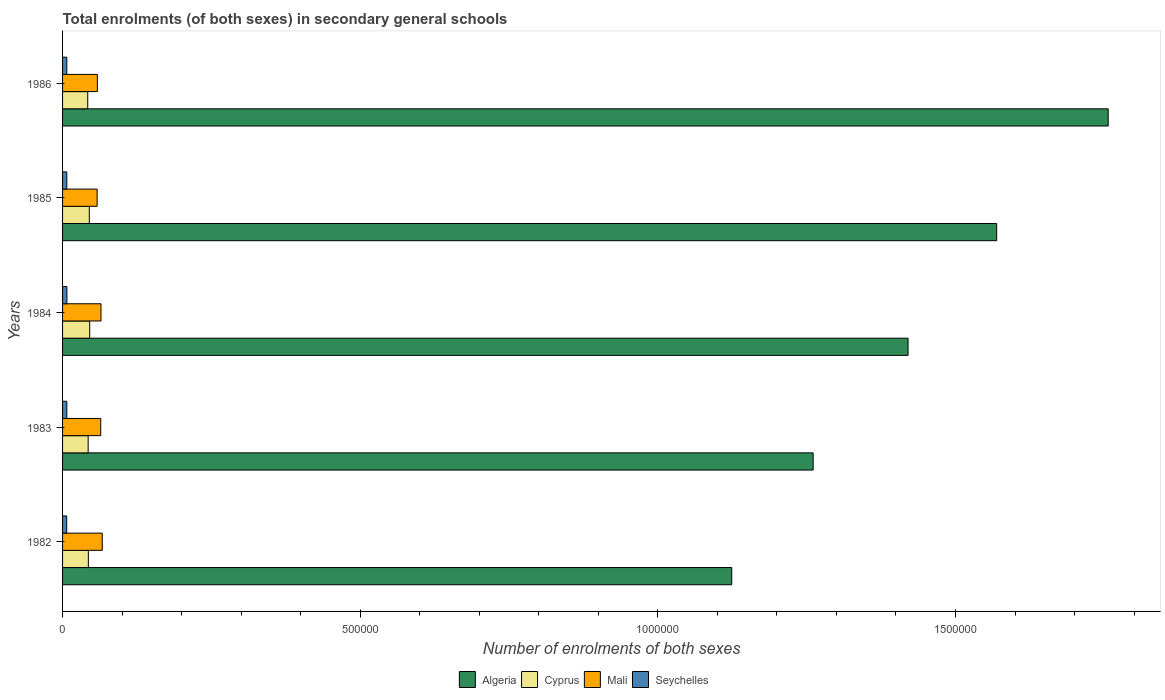How many different coloured bars are there?
Provide a short and direct response. 4. How many groups of bars are there?
Provide a short and direct response. 5. Are the number of bars per tick equal to the number of legend labels?
Your response must be concise. Yes. Are the number of bars on each tick of the Y-axis equal?
Provide a succinct answer. Yes. How many bars are there on the 4th tick from the top?
Make the answer very short. 4. In how many cases, is the number of bars for a given year not equal to the number of legend labels?
Ensure brevity in your answer.  0. What is the number of enrolments in secondary schools in Mali in 1982?
Provide a short and direct response. 6.67e+04. Across all years, what is the maximum number of enrolments in secondary schools in Mali?
Your answer should be compact. 6.67e+04. Across all years, what is the minimum number of enrolments in secondary schools in Mali?
Your answer should be very brief. 5.81e+04. What is the total number of enrolments in secondary schools in Algeria in the graph?
Give a very brief answer. 7.13e+06. What is the difference between the number of enrolments in secondary schools in Mali in 1982 and that in 1983?
Provide a short and direct response. 2521. What is the difference between the number of enrolments in secondary schools in Seychelles in 1983 and the number of enrolments in secondary schools in Cyprus in 1986?
Provide a short and direct response. -3.51e+04. What is the average number of enrolments in secondary schools in Algeria per year?
Provide a short and direct response. 1.43e+06. In the year 1983, what is the difference between the number of enrolments in secondary schools in Cyprus and number of enrolments in secondary schools in Mali?
Offer a terse response. -2.11e+04. In how many years, is the number of enrolments in secondary schools in Algeria greater than 500000 ?
Make the answer very short. 5. What is the ratio of the number of enrolments in secondary schools in Cyprus in 1983 to that in 1986?
Ensure brevity in your answer.  1.02. Is the number of enrolments in secondary schools in Algeria in 1983 less than that in 1986?
Give a very brief answer. Yes. Is the difference between the number of enrolments in secondary schools in Cyprus in 1983 and 1985 greater than the difference between the number of enrolments in secondary schools in Mali in 1983 and 1985?
Your response must be concise. No. What is the difference between the highest and the second highest number of enrolments in secondary schools in Mali?
Give a very brief answer. 2107. What is the difference between the highest and the lowest number of enrolments in secondary schools in Algeria?
Offer a terse response. 6.32e+05. In how many years, is the number of enrolments in secondary schools in Cyprus greater than the average number of enrolments in secondary schools in Cyprus taken over all years?
Your response must be concise. 2. Is the sum of the number of enrolments in secondary schools in Mali in 1983 and 1986 greater than the maximum number of enrolments in secondary schools in Seychelles across all years?
Your response must be concise. Yes. Is it the case that in every year, the sum of the number of enrolments in secondary schools in Algeria and number of enrolments in secondary schools in Cyprus is greater than the sum of number of enrolments in secondary schools in Seychelles and number of enrolments in secondary schools in Mali?
Keep it short and to the point. Yes. What does the 2nd bar from the top in 1986 represents?
Provide a short and direct response. Mali. What does the 2nd bar from the bottom in 1985 represents?
Ensure brevity in your answer.  Cyprus. Is it the case that in every year, the sum of the number of enrolments in secondary schools in Algeria and number of enrolments in secondary schools in Mali is greater than the number of enrolments in secondary schools in Cyprus?
Ensure brevity in your answer.  Yes. How many bars are there?
Give a very brief answer. 20. Are all the bars in the graph horizontal?
Ensure brevity in your answer.  Yes. How many years are there in the graph?
Give a very brief answer. 5. Does the graph contain any zero values?
Make the answer very short. No. How are the legend labels stacked?
Provide a short and direct response. Horizontal. What is the title of the graph?
Your answer should be compact. Total enrolments (of both sexes) in secondary general schools. Does "Middle East & North Africa (all income levels)" appear as one of the legend labels in the graph?
Your answer should be very brief. No. What is the label or title of the X-axis?
Offer a very short reply. Number of enrolments of both sexes. What is the label or title of the Y-axis?
Offer a terse response. Years. What is the Number of enrolments of both sexes in Algeria in 1982?
Ensure brevity in your answer.  1.12e+06. What is the Number of enrolments of both sexes in Cyprus in 1982?
Ensure brevity in your answer.  4.33e+04. What is the Number of enrolments of both sexes in Mali in 1982?
Give a very brief answer. 6.67e+04. What is the Number of enrolments of both sexes of Seychelles in 1982?
Your response must be concise. 6935. What is the Number of enrolments of both sexes of Algeria in 1983?
Make the answer very short. 1.26e+06. What is the Number of enrolments of both sexes in Cyprus in 1983?
Provide a succinct answer. 4.30e+04. What is the Number of enrolments of both sexes of Mali in 1983?
Make the answer very short. 6.41e+04. What is the Number of enrolments of both sexes of Seychelles in 1983?
Keep it short and to the point. 7144. What is the Number of enrolments of both sexes of Algeria in 1984?
Provide a short and direct response. 1.42e+06. What is the Number of enrolments of both sexes of Cyprus in 1984?
Offer a terse response. 4.56e+04. What is the Number of enrolments of both sexes of Mali in 1984?
Ensure brevity in your answer.  6.46e+04. What is the Number of enrolments of both sexes of Seychelles in 1984?
Offer a very short reply. 7254. What is the Number of enrolments of both sexes in Algeria in 1985?
Give a very brief answer. 1.57e+06. What is the Number of enrolments of both sexes of Cyprus in 1985?
Give a very brief answer. 4.49e+04. What is the Number of enrolments of both sexes of Mali in 1985?
Keep it short and to the point. 5.81e+04. What is the Number of enrolments of both sexes in Seychelles in 1985?
Make the answer very short. 7125. What is the Number of enrolments of both sexes in Algeria in 1986?
Provide a short and direct response. 1.76e+06. What is the Number of enrolments of both sexes of Cyprus in 1986?
Make the answer very short. 4.23e+04. What is the Number of enrolments of both sexes in Mali in 1986?
Provide a succinct answer. 5.84e+04. What is the Number of enrolments of both sexes in Seychelles in 1986?
Your answer should be compact. 7101. Across all years, what is the maximum Number of enrolments of both sexes in Algeria?
Your answer should be compact. 1.76e+06. Across all years, what is the maximum Number of enrolments of both sexes of Cyprus?
Offer a terse response. 4.56e+04. Across all years, what is the maximum Number of enrolments of both sexes in Mali?
Provide a short and direct response. 6.67e+04. Across all years, what is the maximum Number of enrolments of both sexes of Seychelles?
Give a very brief answer. 7254. Across all years, what is the minimum Number of enrolments of both sexes in Algeria?
Provide a short and direct response. 1.12e+06. Across all years, what is the minimum Number of enrolments of both sexes of Cyprus?
Your response must be concise. 4.23e+04. Across all years, what is the minimum Number of enrolments of both sexes in Mali?
Make the answer very short. 5.81e+04. Across all years, what is the minimum Number of enrolments of both sexes of Seychelles?
Make the answer very short. 6935. What is the total Number of enrolments of both sexes of Algeria in the graph?
Provide a short and direct response. 7.13e+06. What is the total Number of enrolments of both sexes of Cyprus in the graph?
Ensure brevity in your answer.  2.19e+05. What is the total Number of enrolments of both sexes of Mali in the graph?
Keep it short and to the point. 3.12e+05. What is the total Number of enrolments of both sexes of Seychelles in the graph?
Provide a succinct answer. 3.56e+04. What is the difference between the Number of enrolments of both sexes in Algeria in 1982 and that in 1983?
Provide a succinct answer. -1.37e+05. What is the difference between the Number of enrolments of both sexes of Cyprus in 1982 and that in 1983?
Give a very brief answer. 338. What is the difference between the Number of enrolments of both sexes of Mali in 1982 and that in 1983?
Provide a short and direct response. 2521. What is the difference between the Number of enrolments of both sexes in Seychelles in 1982 and that in 1983?
Your answer should be very brief. -209. What is the difference between the Number of enrolments of both sexes in Algeria in 1982 and that in 1984?
Offer a terse response. -2.96e+05. What is the difference between the Number of enrolments of both sexes in Cyprus in 1982 and that in 1984?
Your answer should be very brief. -2261. What is the difference between the Number of enrolments of both sexes of Mali in 1982 and that in 1984?
Provide a succinct answer. 2107. What is the difference between the Number of enrolments of both sexes of Seychelles in 1982 and that in 1984?
Your response must be concise. -319. What is the difference between the Number of enrolments of both sexes in Algeria in 1982 and that in 1985?
Offer a terse response. -4.45e+05. What is the difference between the Number of enrolments of both sexes in Cyprus in 1982 and that in 1985?
Offer a very short reply. -1557. What is the difference between the Number of enrolments of both sexes in Mali in 1982 and that in 1985?
Your answer should be very brief. 8594. What is the difference between the Number of enrolments of both sexes in Seychelles in 1982 and that in 1985?
Your answer should be compact. -190. What is the difference between the Number of enrolments of both sexes of Algeria in 1982 and that in 1986?
Provide a succinct answer. -6.32e+05. What is the difference between the Number of enrolments of both sexes in Cyprus in 1982 and that in 1986?
Your answer should be very brief. 1053. What is the difference between the Number of enrolments of both sexes of Mali in 1982 and that in 1986?
Keep it short and to the point. 8224. What is the difference between the Number of enrolments of both sexes of Seychelles in 1982 and that in 1986?
Give a very brief answer. -166. What is the difference between the Number of enrolments of both sexes in Algeria in 1983 and that in 1984?
Your answer should be very brief. -1.59e+05. What is the difference between the Number of enrolments of both sexes of Cyprus in 1983 and that in 1984?
Offer a very short reply. -2599. What is the difference between the Number of enrolments of both sexes in Mali in 1983 and that in 1984?
Your answer should be very brief. -414. What is the difference between the Number of enrolments of both sexes in Seychelles in 1983 and that in 1984?
Keep it short and to the point. -110. What is the difference between the Number of enrolments of both sexes in Algeria in 1983 and that in 1985?
Offer a very short reply. -3.08e+05. What is the difference between the Number of enrolments of both sexes in Cyprus in 1983 and that in 1985?
Provide a succinct answer. -1895. What is the difference between the Number of enrolments of both sexes of Mali in 1983 and that in 1985?
Offer a terse response. 6073. What is the difference between the Number of enrolments of both sexes of Seychelles in 1983 and that in 1985?
Make the answer very short. 19. What is the difference between the Number of enrolments of both sexes of Algeria in 1983 and that in 1986?
Provide a succinct answer. -4.96e+05. What is the difference between the Number of enrolments of both sexes in Cyprus in 1983 and that in 1986?
Give a very brief answer. 715. What is the difference between the Number of enrolments of both sexes in Mali in 1983 and that in 1986?
Your response must be concise. 5703. What is the difference between the Number of enrolments of both sexes in Algeria in 1984 and that in 1985?
Give a very brief answer. -1.49e+05. What is the difference between the Number of enrolments of both sexes in Cyprus in 1984 and that in 1985?
Make the answer very short. 704. What is the difference between the Number of enrolments of both sexes in Mali in 1984 and that in 1985?
Your answer should be compact. 6487. What is the difference between the Number of enrolments of both sexes of Seychelles in 1984 and that in 1985?
Provide a short and direct response. 129. What is the difference between the Number of enrolments of both sexes of Algeria in 1984 and that in 1986?
Keep it short and to the point. -3.36e+05. What is the difference between the Number of enrolments of both sexes of Cyprus in 1984 and that in 1986?
Ensure brevity in your answer.  3314. What is the difference between the Number of enrolments of both sexes in Mali in 1984 and that in 1986?
Your response must be concise. 6117. What is the difference between the Number of enrolments of both sexes of Seychelles in 1984 and that in 1986?
Your answer should be very brief. 153. What is the difference between the Number of enrolments of both sexes in Algeria in 1985 and that in 1986?
Provide a succinct answer. -1.87e+05. What is the difference between the Number of enrolments of both sexes in Cyprus in 1985 and that in 1986?
Make the answer very short. 2610. What is the difference between the Number of enrolments of both sexes of Mali in 1985 and that in 1986?
Your response must be concise. -370. What is the difference between the Number of enrolments of both sexes in Seychelles in 1985 and that in 1986?
Make the answer very short. 24. What is the difference between the Number of enrolments of both sexes in Algeria in 1982 and the Number of enrolments of both sexes in Cyprus in 1983?
Provide a short and direct response. 1.08e+06. What is the difference between the Number of enrolments of both sexes of Algeria in 1982 and the Number of enrolments of both sexes of Mali in 1983?
Make the answer very short. 1.06e+06. What is the difference between the Number of enrolments of both sexes of Algeria in 1982 and the Number of enrolments of both sexes of Seychelles in 1983?
Offer a very short reply. 1.12e+06. What is the difference between the Number of enrolments of both sexes of Cyprus in 1982 and the Number of enrolments of both sexes of Mali in 1983?
Provide a succinct answer. -2.08e+04. What is the difference between the Number of enrolments of both sexes of Cyprus in 1982 and the Number of enrolments of both sexes of Seychelles in 1983?
Your response must be concise. 3.62e+04. What is the difference between the Number of enrolments of both sexes in Mali in 1982 and the Number of enrolments of both sexes in Seychelles in 1983?
Provide a short and direct response. 5.95e+04. What is the difference between the Number of enrolments of both sexes in Algeria in 1982 and the Number of enrolments of both sexes in Cyprus in 1984?
Keep it short and to the point. 1.08e+06. What is the difference between the Number of enrolments of both sexes of Algeria in 1982 and the Number of enrolments of both sexes of Mali in 1984?
Ensure brevity in your answer.  1.06e+06. What is the difference between the Number of enrolments of both sexes in Algeria in 1982 and the Number of enrolments of both sexes in Seychelles in 1984?
Provide a succinct answer. 1.12e+06. What is the difference between the Number of enrolments of both sexes in Cyprus in 1982 and the Number of enrolments of both sexes in Mali in 1984?
Make the answer very short. -2.12e+04. What is the difference between the Number of enrolments of both sexes in Cyprus in 1982 and the Number of enrolments of both sexes in Seychelles in 1984?
Make the answer very short. 3.61e+04. What is the difference between the Number of enrolments of both sexes in Mali in 1982 and the Number of enrolments of both sexes in Seychelles in 1984?
Provide a succinct answer. 5.94e+04. What is the difference between the Number of enrolments of both sexes of Algeria in 1982 and the Number of enrolments of both sexes of Cyprus in 1985?
Keep it short and to the point. 1.08e+06. What is the difference between the Number of enrolments of both sexes in Algeria in 1982 and the Number of enrolments of both sexes in Mali in 1985?
Give a very brief answer. 1.07e+06. What is the difference between the Number of enrolments of both sexes of Algeria in 1982 and the Number of enrolments of both sexes of Seychelles in 1985?
Your answer should be very brief. 1.12e+06. What is the difference between the Number of enrolments of both sexes in Cyprus in 1982 and the Number of enrolments of both sexes in Mali in 1985?
Provide a succinct answer. -1.47e+04. What is the difference between the Number of enrolments of both sexes of Cyprus in 1982 and the Number of enrolments of both sexes of Seychelles in 1985?
Keep it short and to the point. 3.62e+04. What is the difference between the Number of enrolments of both sexes in Mali in 1982 and the Number of enrolments of both sexes in Seychelles in 1985?
Your answer should be very brief. 5.95e+04. What is the difference between the Number of enrolments of both sexes in Algeria in 1982 and the Number of enrolments of both sexes in Cyprus in 1986?
Provide a succinct answer. 1.08e+06. What is the difference between the Number of enrolments of both sexes in Algeria in 1982 and the Number of enrolments of both sexes in Mali in 1986?
Your answer should be compact. 1.07e+06. What is the difference between the Number of enrolments of both sexes of Algeria in 1982 and the Number of enrolments of both sexes of Seychelles in 1986?
Provide a succinct answer. 1.12e+06. What is the difference between the Number of enrolments of both sexes in Cyprus in 1982 and the Number of enrolments of both sexes in Mali in 1986?
Offer a very short reply. -1.51e+04. What is the difference between the Number of enrolments of both sexes in Cyprus in 1982 and the Number of enrolments of both sexes in Seychelles in 1986?
Your response must be concise. 3.62e+04. What is the difference between the Number of enrolments of both sexes of Mali in 1982 and the Number of enrolments of both sexes of Seychelles in 1986?
Provide a succinct answer. 5.96e+04. What is the difference between the Number of enrolments of both sexes in Algeria in 1983 and the Number of enrolments of both sexes in Cyprus in 1984?
Give a very brief answer. 1.22e+06. What is the difference between the Number of enrolments of both sexes in Algeria in 1983 and the Number of enrolments of both sexes in Mali in 1984?
Your answer should be compact. 1.20e+06. What is the difference between the Number of enrolments of both sexes of Algeria in 1983 and the Number of enrolments of both sexes of Seychelles in 1984?
Make the answer very short. 1.25e+06. What is the difference between the Number of enrolments of both sexes of Cyprus in 1983 and the Number of enrolments of both sexes of Mali in 1984?
Give a very brief answer. -2.16e+04. What is the difference between the Number of enrolments of both sexes of Cyprus in 1983 and the Number of enrolments of both sexes of Seychelles in 1984?
Offer a very short reply. 3.57e+04. What is the difference between the Number of enrolments of both sexes of Mali in 1983 and the Number of enrolments of both sexes of Seychelles in 1984?
Your response must be concise. 5.69e+04. What is the difference between the Number of enrolments of both sexes in Algeria in 1983 and the Number of enrolments of both sexes in Cyprus in 1985?
Your answer should be very brief. 1.22e+06. What is the difference between the Number of enrolments of both sexes in Algeria in 1983 and the Number of enrolments of both sexes in Mali in 1985?
Make the answer very short. 1.20e+06. What is the difference between the Number of enrolments of both sexes in Algeria in 1983 and the Number of enrolments of both sexes in Seychelles in 1985?
Offer a very short reply. 1.25e+06. What is the difference between the Number of enrolments of both sexes in Cyprus in 1983 and the Number of enrolments of both sexes in Mali in 1985?
Your answer should be very brief. -1.51e+04. What is the difference between the Number of enrolments of both sexes in Cyprus in 1983 and the Number of enrolments of both sexes in Seychelles in 1985?
Give a very brief answer. 3.59e+04. What is the difference between the Number of enrolments of both sexes in Mali in 1983 and the Number of enrolments of both sexes in Seychelles in 1985?
Offer a terse response. 5.70e+04. What is the difference between the Number of enrolments of both sexes in Algeria in 1983 and the Number of enrolments of both sexes in Cyprus in 1986?
Keep it short and to the point. 1.22e+06. What is the difference between the Number of enrolments of both sexes in Algeria in 1983 and the Number of enrolments of both sexes in Mali in 1986?
Offer a very short reply. 1.20e+06. What is the difference between the Number of enrolments of both sexes of Algeria in 1983 and the Number of enrolments of both sexes of Seychelles in 1986?
Keep it short and to the point. 1.25e+06. What is the difference between the Number of enrolments of both sexes of Cyprus in 1983 and the Number of enrolments of both sexes of Mali in 1986?
Give a very brief answer. -1.54e+04. What is the difference between the Number of enrolments of both sexes in Cyprus in 1983 and the Number of enrolments of both sexes in Seychelles in 1986?
Keep it short and to the point. 3.59e+04. What is the difference between the Number of enrolments of both sexes of Mali in 1983 and the Number of enrolments of both sexes of Seychelles in 1986?
Your response must be concise. 5.70e+04. What is the difference between the Number of enrolments of both sexes in Algeria in 1984 and the Number of enrolments of both sexes in Cyprus in 1985?
Give a very brief answer. 1.38e+06. What is the difference between the Number of enrolments of both sexes of Algeria in 1984 and the Number of enrolments of both sexes of Mali in 1985?
Keep it short and to the point. 1.36e+06. What is the difference between the Number of enrolments of both sexes in Algeria in 1984 and the Number of enrolments of both sexes in Seychelles in 1985?
Ensure brevity in your answer.  1.41e+06. What is the difference between the Number of enrolments of both sexes in Cyprus in 1984 and the Number of enrolments of both sexes in Mali in 1985?
Provide a short and direct response. -1.25e+04. What is the difference between the Number of enrolments of both sexes in Cyprus in 1984 and the Number of enrolments of both sexes in Seychelles in 1985?
Make the answer very short. 3.85e+04. What is the difference between the Number of enrolments of both sexes of Mali in 1984 and the Number of enrolments of both sexes of Seychelles in 1985?
Give a very brief answer. 5.74e+04. What is the difference between the Number of enrolments of both sexes in Algeria in 1984 and the Number of enrolments of both sexes in Cyprus in 1986?
Keep it short and to the point. 1.38e+06. What is the difference between the Number of enrolments of both sexes of Algeria in 1984 and the Number of enrolments of both sexes of Mali in 1986?
Ensure brevity in your answer.  1.36e+06. What is the difference between the Number of enrolments of both sexes of Algeria in 1984 and the Number of enrolments of both sexes of Seychelles in 1986?
Provide a short and direct response. 1.41e+06. What is the difference between the Number of enrolments of both sexes in Cyprus in 1984 and the Number of enrolments of both sexes in Mali in 1986?
Ensure brevity in your answer.  -1.28e+04. What is the difference between the Number of enrolments of both sexes in Cyprus in 1984 and the Number of enrolments of both sexes in Seychelles in 1986?
Ensure brevity in your answer.  3.85e+04. What is the difference between the Number of enrolments of both sexes in Mali in 1984 and the Number of enrolments of both sexes in Seychelles in 1986?
Ensure brevity in your answer.  5.75e+04. What is the difference between the Number of enrolments of both sexes in Algeria in 1985 and the Number of enrolments of both sexes in Cyprus in 1986?
Offer a very short reply. 1.53e+06. What is the difference between the Number of enrolments of both sexes in Algeria in 1985 and the Number of enrolments of both sexes in Mali in 1986?
Offer a terse response. 1.51e+06. What is the difference between the Number of enrolments of both sexes in Algeria in 1985 and the Number of enrolments of both sexes in Seychelles in 1986?
Ensure brevity in your answer.  1.56e+06. What is the difference between the Number of enrolments of both sexes of Cyprus in 1985 and the Number of enrolments of both sexes of Mali in 1986?
Offer a terse response. -1.36e+04. What is the difference between the Number of enrolments of both sexes in Cyprus in 1985 and the Number of enrolments of both sexes in Seychelles in 1986?
Your answer should be compact. 3.78e+04. What is the difference between the Number of enrolments of both sexes of Mali in 1985 and the Number of enrolments of both sexes of Seychelles in 1986?
Ensure brevity in your answer.  5.10e+04. What is the average Number of enrolments of both sexes of Algeria per year?
Your answer should be compact. 1.43e+06. What is the average Number of enrolments of both sexes of Cyprus per year?
Provide a succinct answer. 4.38e+04. What is the average Number of enrolments of both sexes of Mali per year?
Offer a terse response. 6.24e+04. What is the average Number of enrolments of both sexes in Seychelles per year?
Make the answer very short. 7111.8. In the year 1982, what is the difference between the Number of enrolments of both sexes in Algeria and Number of enrolments of both sexes in Cyprus?
Offer a very short reply. 1.08e+06. In the year 1982, what is the difference between the Number of enrolments of both sexes of Algeria and Number of enrolments of both sexes of Mali?
Ensure brevity in your answer.  1.06e+06. In the year 1982, what is the difference between the Number of enrolments of both sexes of Algeria and Number of enrolments of both sexes of Seychelles?
Keep it short and to the point. 1.12e+06. In the year 1982, what is the difference between the Number of enrolments of both sexes in Cyprus and Number of enrolments of both sexes in Mali?
Your response must be concise. -2.33e+04. In the year 1982, what is the difference between the Number of enrolments of both sexes of Cyprus and Number of enrolments of both sexes of Seychelles?
Offer a terse response. 3.64e+04. In the year 1982, what is the difference between the Number of enrolments of both sexes in Mali and Number of enrolments of both sexes in Seychelles?
Your answer should be compact. 5.97e+04. In the year 1983, what is the difference between the Number of enrolments of both sexes in Algeria and Number of enrolments of both sexes in Cyprus?
Ensure brevity in your answer.  1.22e+06. In the year 1983, what is the difference between the Number of enrolments of both sexes in Algeria and Number of enrolments of both sexes in Mali?
Keep it short and to the point. 1.20e+06. In the year 1983, what is the difference between the Number of enrolments of both sexes in Algeria and Number of enrolments of both sexes in Seychelles?
Make the answer very short. 1.25e+06. In the year 1983, what is the difference between the Number of enrolments of both sexes in Cyprus and Number of enrolments of both sexes in Mali?
Offer a terse response. -2.11e+04. In the year 1983, what is the difference between the Number of enrolments of both sexes of Cyprus and Number of enrolments of both sexes of Seychelles?
Provide a short and direct response. 3.59e+04. In the year 1983, what is the difference between the Number of enrolments of both sexes of Mali and Number of enrolments of both sexes of Seychelles?
Make the answer very short. 5.70e+04. In the year 1984, what is the difference between the Number of enrolments of both sexes of Algeria and Number of enrolments of both sexes of Cyprus?
Make the answer very short. 1.37e+06. In the year 1984, what is the difference between the Number of enrolments of both sexes in Algeria and Number of enrolments of both sexes in Mali?
Make the answer very short. 1.36e+06. In the year 1984, what is the difference between the Number of enrolments of both sexes of Algeria and Number of enrolments of both sexes of Seychelles?
Keep it short and to the point. 1.41e+06. In the year 1984, what is the difference between the Number of enrolments of both sexes in Cyprus and Number of enrolments of both sexes in Mali?
Your response must be concise. -1.90e+04. In the year 1984, what is the difference between the Number of enrolments of both sexes in Cyprus and Number of enrolments of both sexes in Seychelles?
Keep it short and to the point. 3.83e+04. In the year 1984, what is the difference between the Number of enrolments of both sexes in Mali and Number of enrolments of both sexes in Seychelles?
Ensure brevity in your answer.  5.73e+04. In the year 1985, what is the difference between the Number of enrolments of both sexes of Algeria and Number of enrolments of both sexes of Cyprus?
Your answer should be compact. 1.52e+06. In the year 1985, what is the difference between the Number of enrolments of both sexes of Algeria and Number of enrolments of both sexes of Mali?
Make the answer very short. 1.51e+06. In the year 1985, what is the difference between the Number of enrolments of both sexes of Algeria and Number of enrolments of both sexes of Seychelles?
Offer a terse response. 1.56e+06. In the year 1985, what is the difference between the Number of enrolments of both sexes in Cyprus and Number of enrolments of both sexes in Mali?
Give a very brief answer. -1.32e+04. In the year 1985, what is the difference between the Number of enrolments of both sexes of Cyprus and Number of enrolments of both sexes of Seychelles?
Offer a very short reply. 3.78e+04. In the year 1985, what is the difference between the Number of enrolments of both sexes in Mali and Number of enrolments of both sexes in Seychelles?
Give a very brief answer. 5.10e+04. In the year 1986, what is the difference between the Number of enrolments of both sexes in Algeria and Number of enrolments of both sexes in Cyprus?
Ensure brevity in your answer.  1.71e+06. In the year 1986, what is the difference between the Number of enrolments of both sexes of Algeria and Number of enrolments of both sexes of Mali?
Offer a very short reply. 1.70e+06. In the year 1986, what is the difference between the Number of enrolments of both sexes of Algeria and Number of enrolments of both sexes of Seychelles?
Your response must be concise. 1.75e+06. In the year 1986, what is the difference between the Number of enrolments of both sexes of Cyprus and Number of enrolments of both sexes of Mali?
Provide a short and direct response. -1.62e+04. In the year 1986, what is the difference between the Number of enrolments of both sexes in Cyprus and Number of enrolments of both sexes in Seychelles?
Make the answer very short. 3.52e+04. In the year 1986, what is the difference between the Number of enrolments of both sexes of Mali and Number of enrolments of both sexes of Seychelles?
Provide a succinct answer. 5.13e+04. What is the ratio of the Number of enrolments of both sexes in Algeria in 1982 to that in 1983?
Offer a terse response. 0.89. What is the ratio of the Number of enrolments of both sexes in Cyprus in 1982 to that in 1983?
Provide a succinct answer. 1.01. What is the ratio of the Number of enrolments of both sexes of Mali in 1982 to that in 1983?
Make the answer very short. 1.04. What is the ratio of the Number of enrolments of both sexes in Seychelles in 1982 to that in 1983?
Your answer should be compact. 0.97. What is the ratio of the Number of enrolments of both sexes in Algeria in 1982 to that in 1984?
Provide a succinct answer. 0.79. What is the ratio of the Number of enrolments of both sexes in Cyprus in 1982 to that in 1984?
Your response must be concise. 0.95. What is the ratio of the Number of enrolments of both sexes in Mali in 1982 to that in 1984?
Keep it short and to the point. 1.03. What is the ratio of the Number of enrolments of both sexes of Seychelles in 1982 to that in 1984?
Your answer should be compact. 0.96. What is the ratio of the Number of enrolments of both sexes in Algeria in 1982 to that in 1985?
Provide a succinct answer. 0.72. What is the ratio of the Number of enrolments of both sexes in Cyprus in 1982 to that in 1985?
Offer a very short reply. 0.97. What is the ratio of the Number of enrolments of both sexes in Mali in 1982 to that in 1985?
Your response must be concise. 1.15. What is the ratio of the Number of enrolments of both sexes in Seychelles in 1982 to that in 1985?
Offer a very short reply. 0.97. What is the ratio of the Number of enrolments of both sexes in Algeria in 1982 to that in 1986?
Offer a terse response. 0.64. What is the ratio of the Number of enrolments of both sexes of Cyprus in 1982 to that in 1986?
Your response must be concise. 1.02. What is the ratio of the Number of enrolments of both sexes in Mali in 1982 to that in 1986?
Offer a terse response. 1.14. What is the ratio of the Number of enrolments of both sexes of Seychelles in 1982 to that in 1986?
Provide a short and direct response. 0.98. What is the ratio of the Number of enrolments of both sexes in Algeria in 1983 to that in 1984?
Your answer should be very brief. 0.89. What is the ratio of the Number of enrolments of both sexes of Cyprus in 1983 to that in 1984?
Keep it short and to the point. 0.94. What is the ratio of the Number of enrolments of both sexes of Seychelles in 1983 to that in 1984?
Your answer should be compact. 0.98. What is the ratio of the Number of enrolments of both sexes in Algeria in 1983 to that in 1985?
Provide a succinct answer. 0.8. What is the ratio of the Number of enrolments of both sexes in Cyprus in 1983 to that in 1985?
Provide a short and direct response. 0.96. What is the ratio of the Number of enrolments of both sexes in Mali in 1983 to that in 1985?
Make the answer very short. 1.1. What is the ratio of the Number of enrolments of both sexes of Seychelles in 1983 to that in 1985?
Offer a terse response. 1. What is the ratio of the Number of enrolments of both sexes in Algeria in 1983 to that in 1986?
Your response must be concise. 0.72. What is the ratio of the Number of enrolments of both sexes in Cyprus in 1983 to that in 1986?
Your answer should be very brief. 1.02. What is the ratio of the Number of enrolments of both sexes of Mali in 1983 to that in 1986?
Offer a very short reply. 1.1. What is the ratio of the Number of enrolments of both sexes of Seychelles in 1983 to that in 1986?
Give a very brief answer. 1.01. What is the ratio of the Number of enrolments of both sexes of Algeria in 1984 to that in 1985?
Provide a short and direct response. 0.91. What is the ratio of the Number of enrolments of both sexes in Cyprus in 1984 to that in 1985?
Your answer should be compact. 1.02. What is the ratio of the Number of enrolments of both sexes of Mali in 1984 to that in 1985?
Your response must be concise. 1.11. What is the ratio of the Number of enrolments of both sexes of Seychelles in 1984 to that in 1985?
Provide a succinct answer. 1.02. What is the ratio of the Number of enrolments of both sexes of Algeria in 1984 to that in 1986?
Provide a succinct answer. 0.81. What is the ratio of the Number of enrolments of both sexes in Cyprus in 1984 to that in 1986?
Keep it short and to the point. 1.08. What is the ratio of the Number of enrolments of both sexes of Mali in 1984 to that in 1986?
Provide a succinct answer. 1.1. What is the ratio of the Number of enrolments of both sexes of Seychelles in 1984 to that in 1986?
Keep it short and to the point. 1.02. What is the ratio of the Number of enrolments of both sexes of Algeria in 1985 to that in 1986?
Your answer should be very brief. 0.89. What is the ratio of the Number of enrolments of both sexes in Cyprus in 1985 to that in 1986?
Your answer should be compact. 1.06. What is the ratio of the Number of enrolments of both sexes in Mali in 1985 to that in 1986?
Provide a succinct answer. 0.99. What is the difference between the highest and the second highest Number of enrolments of both sexes in Algeria?
Offer a terse response. 1.87e+05. What is the difference between the highest and the second highest Number of enrolments of both sexes in Cyprus?
Keep it short and to the point. 704. What is the difference between the highest and the second highest Number of enrolments of both sexes of Mali?
Offer a terse response. 2107. What is the difference between the highest and the second highest Number of enrolments of both sexes in Seychelles?
Make the answer very short. 110. What is the difference between the highest and the lowest Number of enrolments of both sexes in Algeria?
Provide a succinct answer. 6.32e+05. What is the difference between the highest and the lowest Number of enrolments of both sexes in Cyprus?
Keep it short and to the point. 3314. What is the difference between the highest and the lowest Number of enrolments of both sexes of Mali?
Ensure brevity in your answer.  8594. What is the difference between the highest and the lowest Number of enrolments of both sexes in Seychelles?
Provide a short and direct response. 319. 